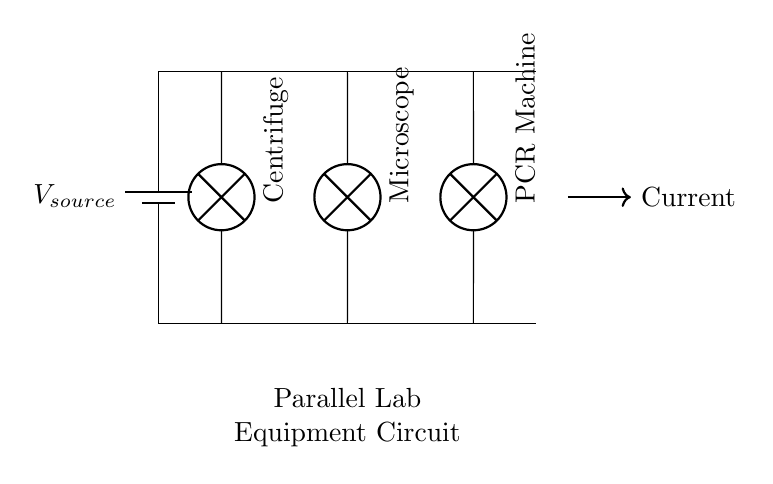What is the type of circuit represented? The circuit is a parallel circuit, identified by the configuration where all devices are connected across the same two nodes, allowing them to operate independently.
Answer: Parallel circuit What is the voltage of the battery? The voltage is not explicitly given in the diagram, but it indicates a source labeled as V source. Therefore, it can be inferred that it is the source voltage that is shared among all devices.
Answer: V source How many lab equipment devices are connected? There are three devices connected, which include a centrifuge, a microscope, and a PCR machine, as indicated by the labels on the circuit diagram.
Answer: Three Which equipment is positioned at the leftmost connection? The centrifuge is the leftmost device, shown specifically in the diagram as connected to the top and bottom nodes of the circuit.
Answer: Centrifuge What does the arrow represent in the circuit diagram? The arrow indicates the direction of current flow, demonstrating how the current moves through the circuit from the battery to the connected devices.
Answer: Current If one device fails, what happens to the others? In a parallel circuit, if one device fails, the others remain operational because they have separate paths for current. This characteristic is unique to parallel configurations.
Answer: Others remain operational 